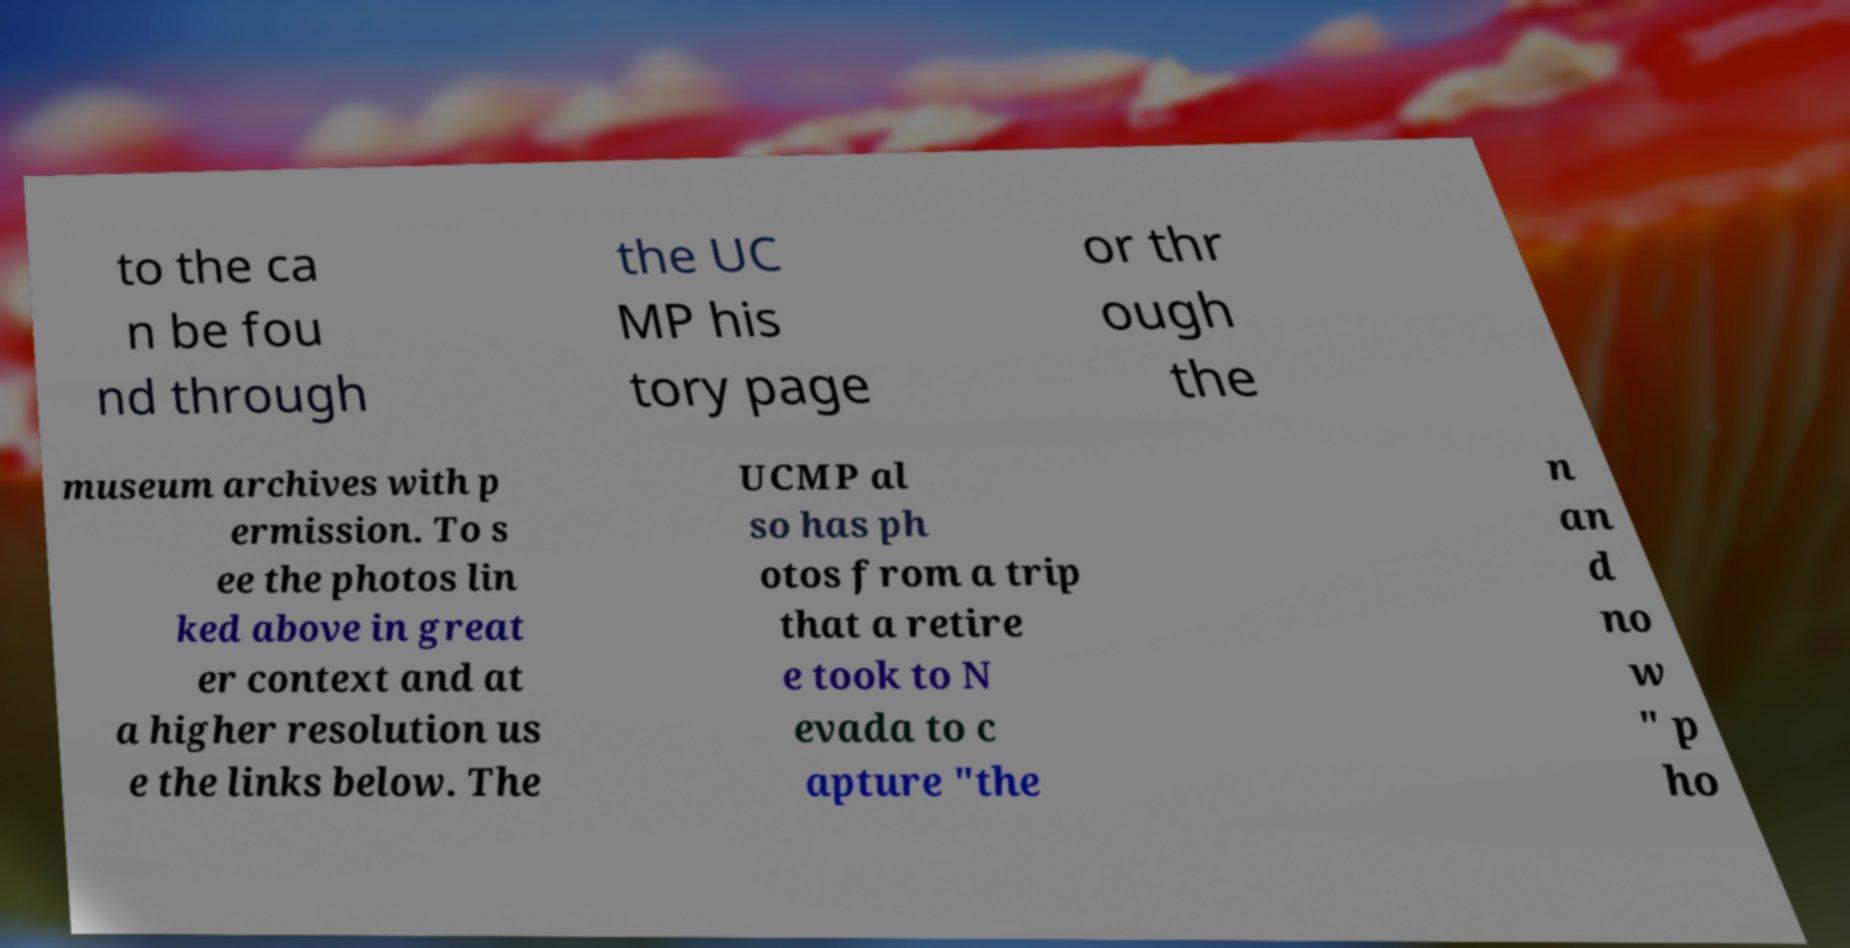Can you accurately transcribe the text from the provided image for me? to the ca n be fou nd through the UC MP his tory page or thr ough the museum archives with p ermission. To s ee the photos lin ked above in great er context and at a higher resolution us e the links below. The UCMP al so has ph otos from a trip that a retire e took to N evada to c apture "the n an d no w " p ho 